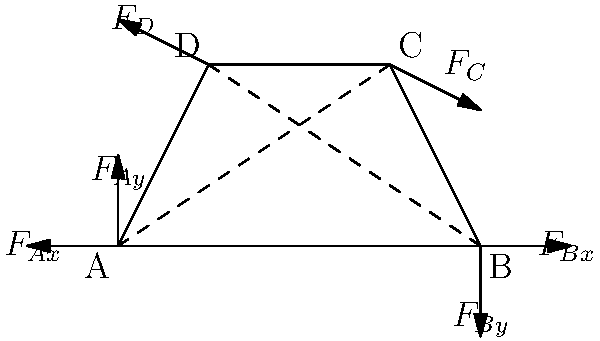In the four-bar mechanism shown, determine the relationship between the forces $F_C$ and $F_D$ for the system to be in static equilibrium. Assume all joints are frictionless and the weight of the links is negligible. To solve this problem, we'll follow these steps:

1) For static equilibrium, the sum of forces and moments must be zero.

2) Let's start by considering the moment equilibrium about point A:
   $$M_A = F_D \cdot AD \cdot \sin(\angle DAB) - F_C \cdot AC \cdot \sin(\angle CAB) = 0$$

3) From the geometry of the mechanism:
   $AD = \sqrt{1^2 + 2^2} = \sqrt{5}$
   $AC = \sqrt{3^2 + 2^2} = \sqrt{13}$
   $\sin(\angle DAB) = \frac{2}{\sqrt{5}}$
   $\sin(\angle CAB) = \frac{2}{\sqrt{13}}$

4) Substituting these into the moment equation:
   $$F_D \cdot \sqrt{5} \cdot \frac{2}{\sqrt{5}} - F_C \cdot \sqrt{13} \cdot \frac{2}{\sqrt{13}} = 0$$

5) Simplifying:
   $$2F_D - 2F_C = 0$$

6) Therefore:
   $$F_D = F_C$$

This relationship ensures that the moments about point A are balanced. The same relationship would be obtained if we considered moments about point B, due to the symmetry of the problem.
Answer: $F_D = F_C$ 